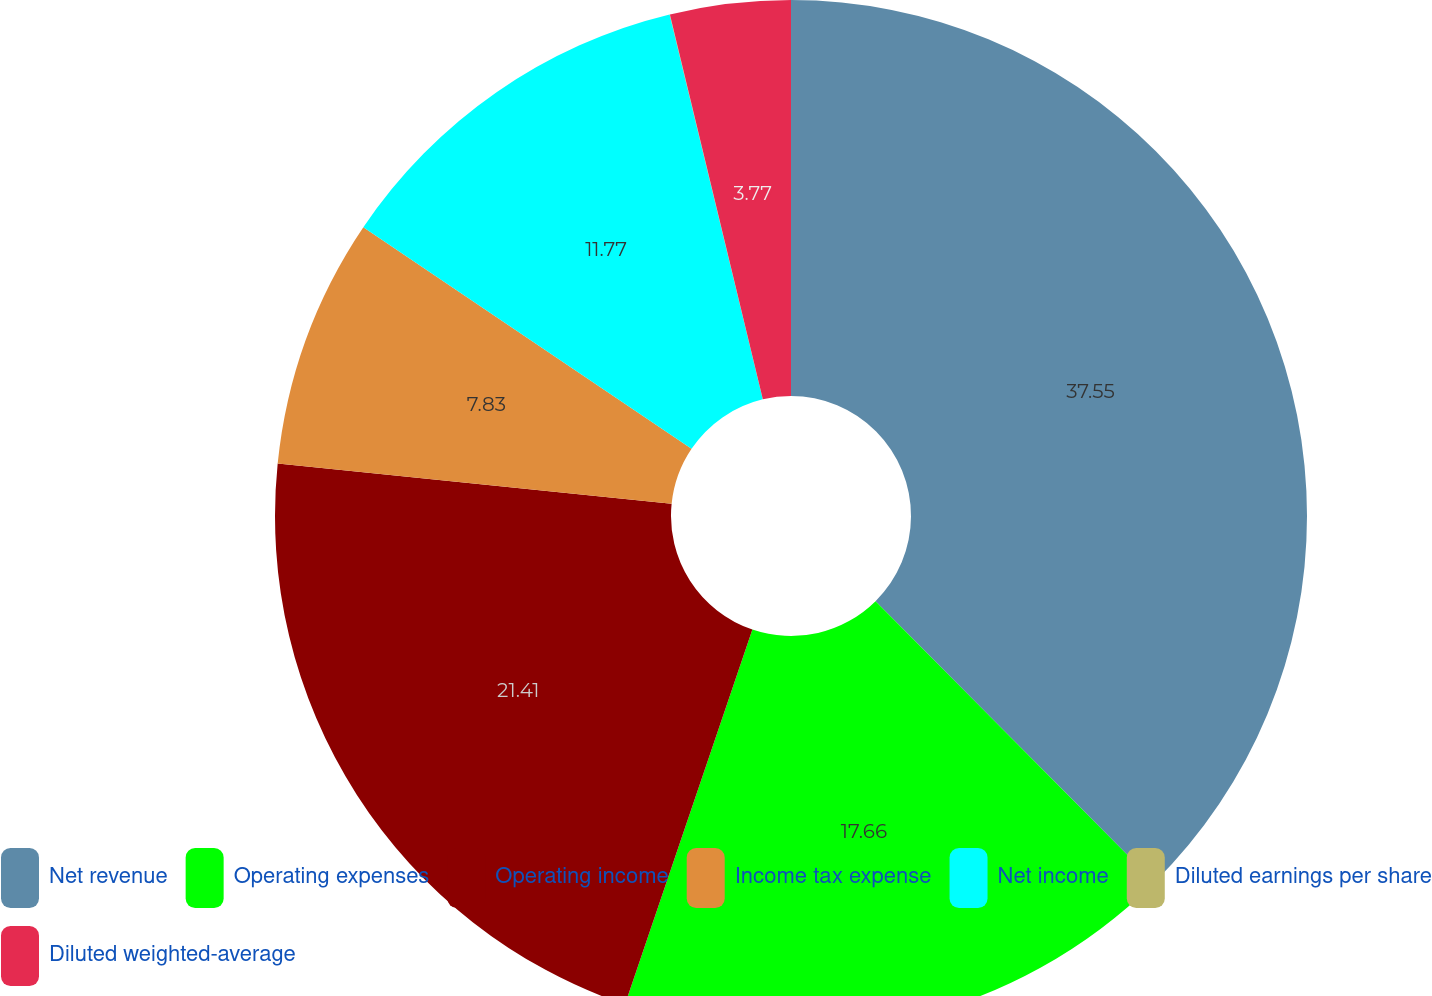Convert chart. <chart><loc_0><loc_0><loc_500><loc_500><pie_chart><fcel>Net revenue<fcel>Operating expenses<fcel>Operating income<fcel>Income tax expense<fcel>Net income<fcel>Diluted earnings per share<fcel>Diluted weighted-average<nl><fcel>37.56%<fcel>17.66%<fcel>21.41%<fcel>7.83%<fcel>11.77%<fcel>0.01%<fcel>3.77%<nl></chart> 